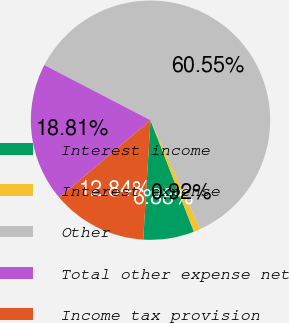<chart> <loc_0><loc_0><loc_500><loc_500><pie_chart><fcel>Interest income<fcel>Interest expense<fcel>Other<fcel>Total other expense net<fcel>Income tax provision<nl><fcel>6.88%<fcel>0.92%<fcel>60.55%<fcel>18.81%<fcel>12.84%<nl></chart> 